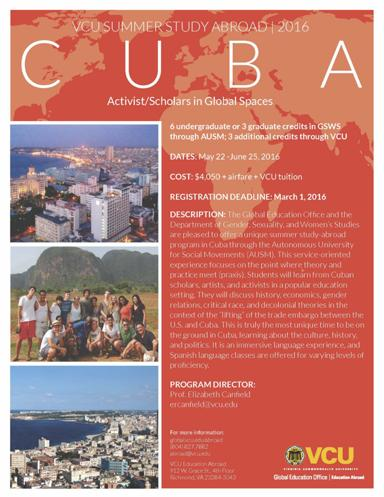What is the study abroad program mentioned in the image? The study abroad program featured in the image is the 'VCU Summer Study Abroad 2016.' This unique program is titled 'Activist Scholars in Global Spaces' and offers participants a deep dive into various academic studies while being immersed in a different culture. 